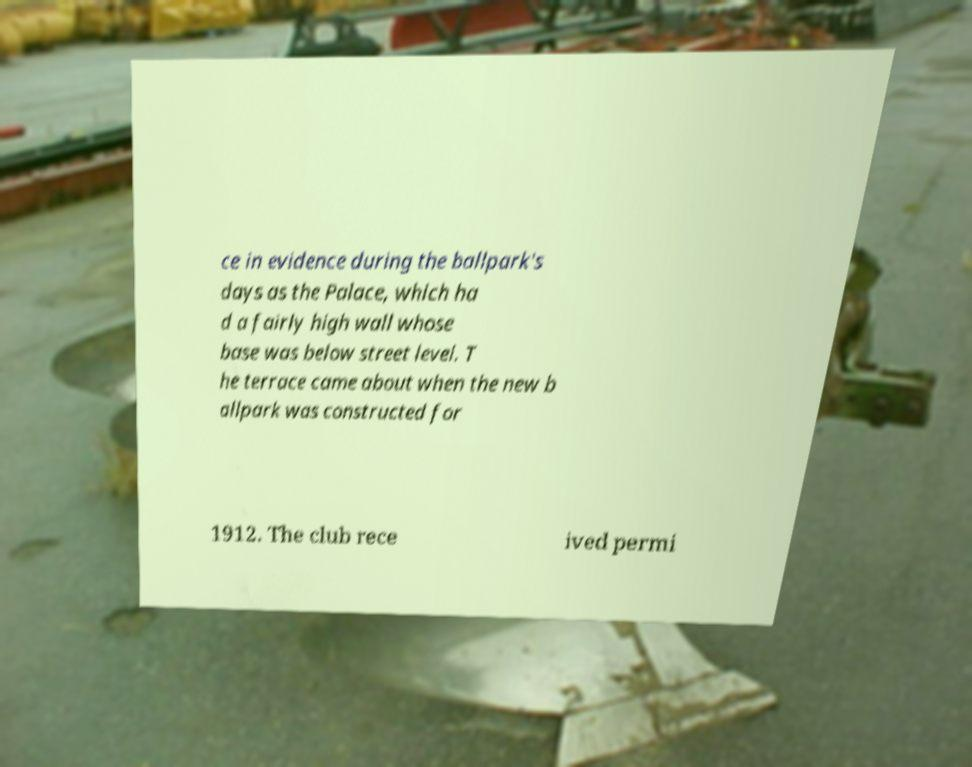Please read and relay the text visible in this image. What does it say? ce in evidence during the ballpark's days as the Palace, which ha d a fairly high wall whose base was below street level. T he terrace came about when the new b allpark was constructed for 1912. The club rece ived permi 